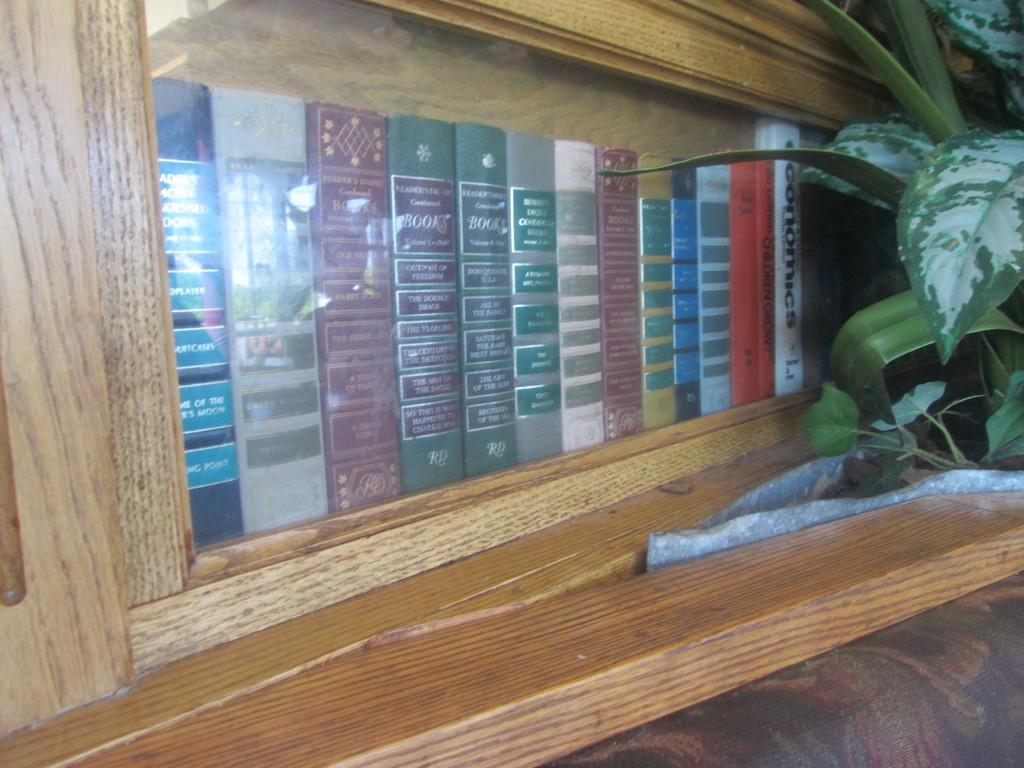Describe this image in one or two sentences. In this picture there is bookshelf in the center of the image, in which there are books and there is a plant on the right side of the image. 